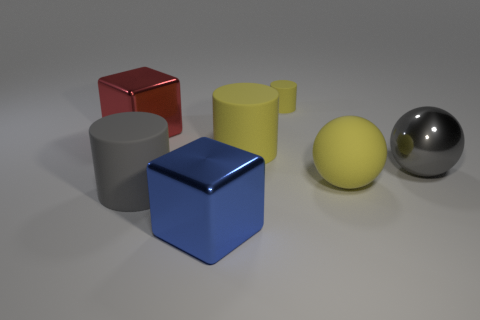Subtract all large yellow cylinders. How many cylinders are left? 2 Add 2 small things. How many objects exist? 9 Subtract all gray cylinders. How many cylinders are left? 2 Subtract all cylinders. How many objects are left? 4 Subtract 1 cubes. How many cubes are left? 1 Subtract all red cubes. Subtract all yellow cylinders. How many cubes are left? 1 Subtract all brown cylinders. How many red blocks are left? 1 Subtract all big yellow cylinders. Subtract all balls. How many objects are left? 4 Add 7 yellow matte spheres. How many yellow matte spheres are left? 8 Add 4 big rubber things. How many big rubber things exist? 7 